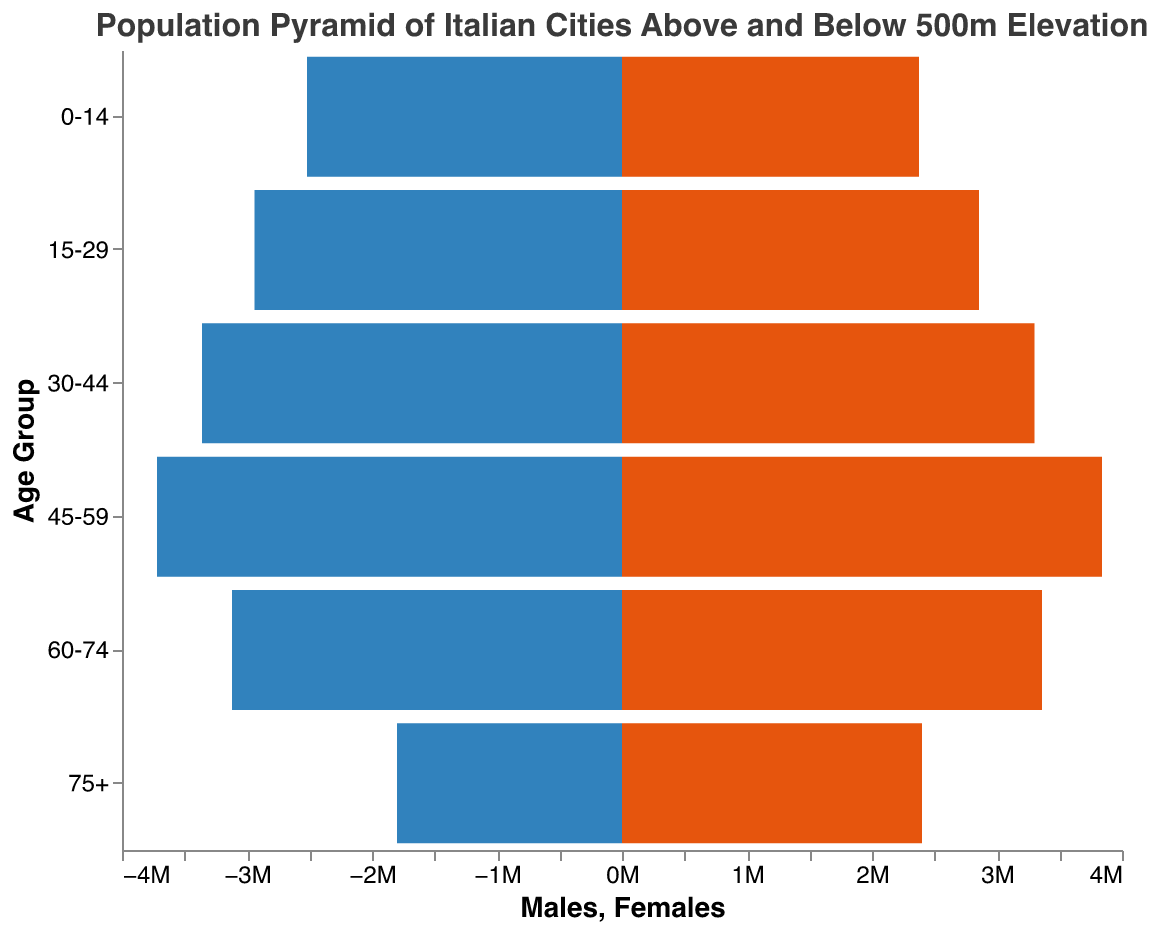What is the title of the figure? The title of the figure is mentioned at the top and reads, "Population Pyramid of Italian Cities Above and Below 500m Elevation".
Answer: Population Pyramid of Italian Cities Above and Below 500m Elevation Which age group has the highest total population below 500m? The age group with the highest total population below 500m can be determined by comparing the heights of the bars representing the male and female populations below 500m. The "45-59" age group has the highest combined height.
Answer: 45-59 How many people aged 60-74 live above 500m? To find this, add the number of males and females aged 60-74 living above 500m. The numbers are 520,000 males and 560,000 females, so 520,000 + 560,000 = 1,080,000.
Answer: 1,080,000 Compare the population of males and females in the 75+ age group living above 500m. Which is higher and by how much? Subtract the number of males from the number of females in the 75+ age group living above 500m. There are 400,000 females and 300,000 males, so 400,000 - 300,000 = 100,000 more females.
Answer: Females by 100,000 Which age group has more females than males below 500m, and by how many? Compare the population of females and males in each age group below 500m. The "45-59" age group has 100,000 more females than males.
Answer: 45-59 by 100,000 What is the total number of females in the 30-44 age group? To find the total number of females in the 30-44 age group, add the females below 500m and above 500m: 2,750,000 + 550,000 = 3,300,000.
Answer: 3,300,000 In the 0-14 age group, are there more males or females and by what margin? Compare the number of males and females in the 0-14 age group below and above 500m. Below 500m: 2,100,000 males and 1,980,000 females; Above 500m: 420,000 males and 396,000 females. Total: 2,520,000 males and 2,376,000 females, so 2,520,000 - 2,376,000 = 144,000 more males.
Answer: Males by 144,000 What is the total population of Italian cities above 500m for all age groups combined? Sum the populations above 500m for all age groups and genders: (420,000 + 396,000) + (490,000 + 476,000) + (560,000 + 550,000) + (620,000 + 640,000) + (520,000 + 560,000) + (300,000 + 400,000) = 5,932,000.
Answer: 5,932,000 Compare the population of the 0-14 age group below 500m with the 75+ age group below 500m. Add the males and females for each age group below 500m and compare. 0-14: 2,100,000 males + 1,980,000 females = 4,080,000; 75+: 1,500,000 males + 2,000,000 females = 3,500,000. There are 580,000 more people in the 0-14 age group.
Answer: 0-14 by 580,000 